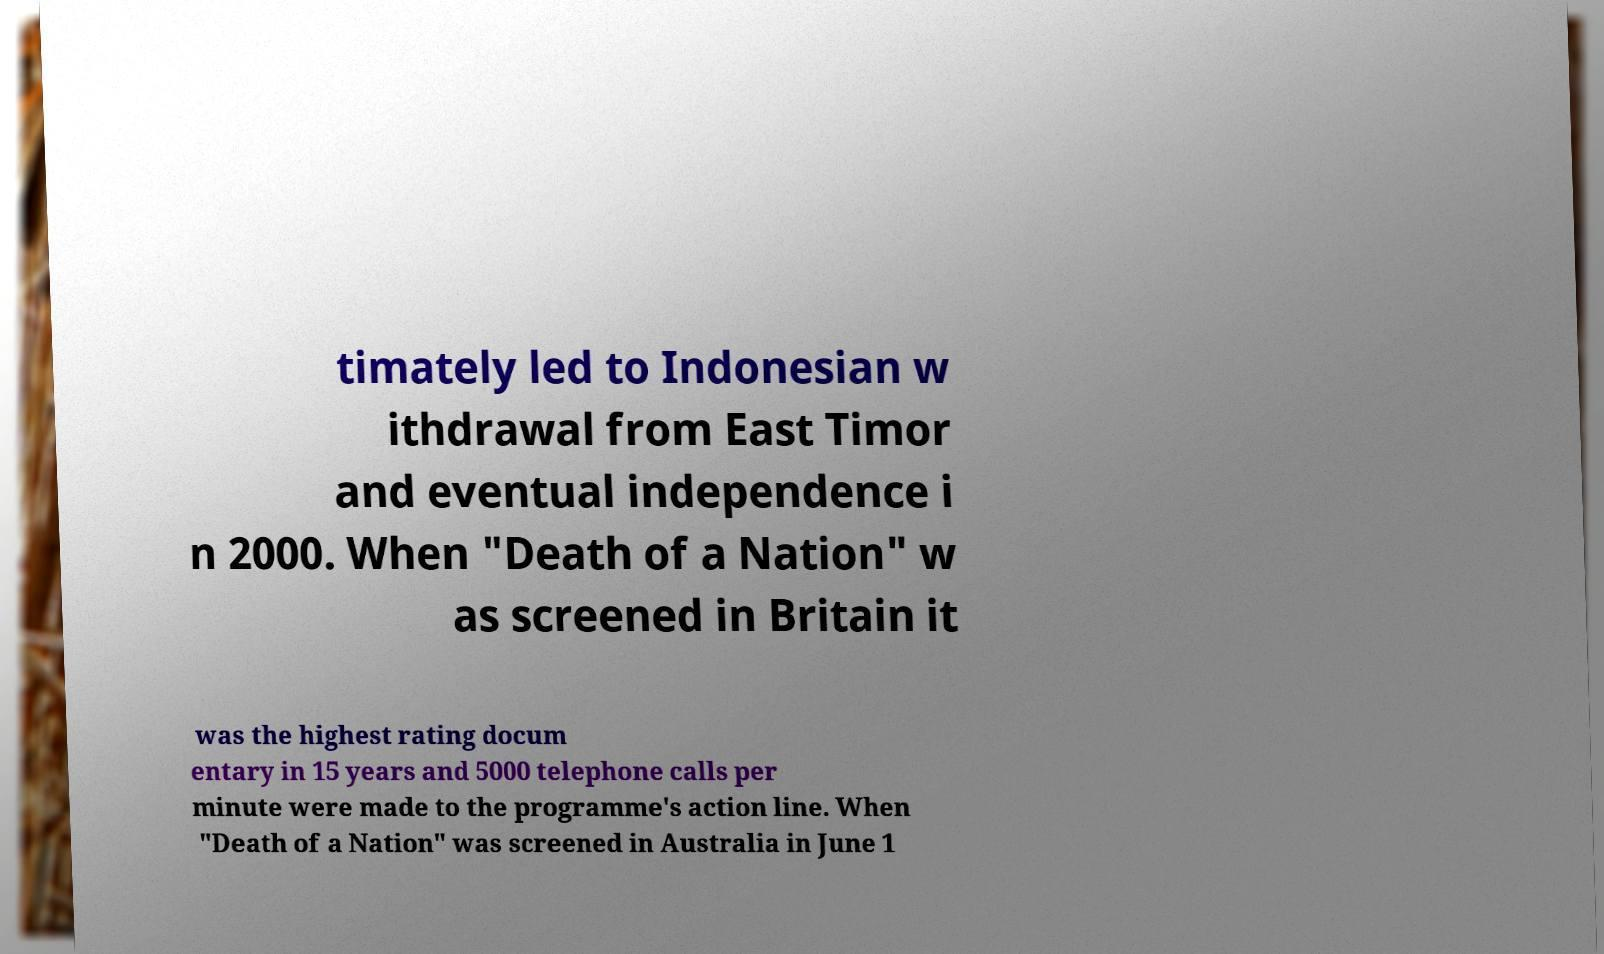For documentation purposes, I need the text within this image transcribed. Could you provide that? timately led to Indonesian w ithdrawal from East Timor and eventual independence i n 2000. When "Death of a Nation" w as screened in Britain it was the highest rating docum entary in 15 years and 5000 telephone calls per minute were made to the programme's action line. When "Death of a Nation" was screened in Australia in June 1 